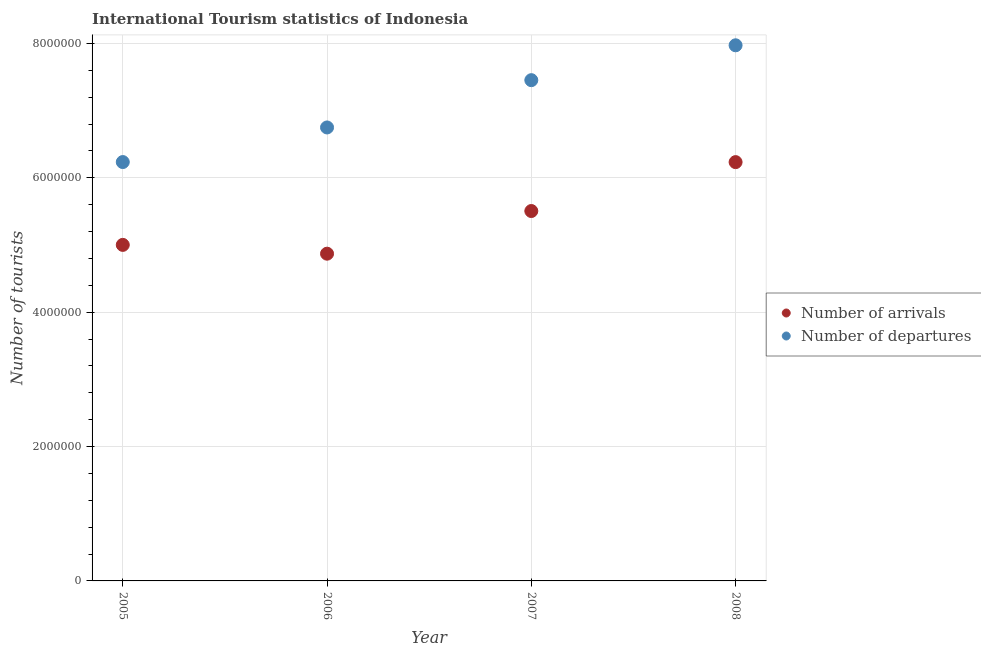How many different coloured dotlines are there?
Ensure brevity in your answer.  2. Is the number of dotlines equal to the number of legend labels?
Your response must be concise. Yes. What is the number of tourist departures in 2008?
Make the answer very short. 7.97e+06. Across all years, what is the maximum number of tourist departures?
Offer a very short reply. 7.97e+06. Across all years, what is the minimum number of tourist departures?
Keep it short and to the point. 6.24e+06. What is the total number of tourist arrivals in the graph?
Provide a short and direct response. 2.16e+07. What is the difference between the number of tourist arrivals in 2005 and that in 2006?
Make the answer very short. 1.31e+05. What is the difference between the number of tourist arrivals in 2006 and the number of tourist departures in 2008?
Your answer should be very brief. -3.10e+06. What is the average number of tourist arrivals per year?
Ensure brevity in your answer.  5.40e+06. In the year 2008, what is the difference between the number of tourist arrivals and number of tourist departures?
Offer a very short reply. -1.74e+06. What is the ratio of the number of tourist arrivals in 2005 to that in 2008?
Your response must be concise. 0.8. Is the difference between the number of tourist departures in 2005 and 2008 greater than the difference between the number of tourist arrivals in 2005 and 2008?
Offer a terse response. No. What is the difference between the highest and the second highest number of tourist departures?
Ensure brevity in your answer.  5.19e+05. What is the difference between the highest and the lowest number of tourist departures?
Your answer should be very brief. 1.74e+06. In how many years, is the number of tourist arrivals greater than the average number of tourist arrivals taken over all years?
Your answer should be very brief. 2. Is the number of tourist departures strictly less than the number of tourist arrivals over the years?
Your answer should be very brief. No. How many years are there in the graph?
Offer a very short reply. 4. Are the values on the major ticks of Y-axis written in scientific E-notation?
Make the answer very short. No. Does the graph contain grids?
Your response must be concise. Yes. How many legend labels are there?
Provide a succinct answer. 2. How are the legend labels stacked?
Make the answer very short. Vertical. What is the title of the graph?
Ensure brevity in your answer.  International Tourism statistics of Indonesia. Does "Lowest 20% of population" appear as one of the legend labels in the graph?
Ensure brevity in your answer.  No. What is the label or title of the X-axis?
Provide a short and direct response. Year. What is the label or title of the Y-axis?
Offer a very short reply. Number of tourists. What is the Number of tourists in Number of arrivals in 2005?
Ensure brevity in your answer.  5.00e+06. What is the Number of tourists of Number of departures in 2005?
Offer a terse response. 6.24e+06. What is the Number of tourists of Number of arrivals in 2006?
Offer a terse response. 4.87e+06. What is the Number of tourists of Number of departures in 2006?
Your answer should be compact. 6.75e+06. What is the Number of tourists in Number of arrivals in 2007?
Your answer should be compact. 5.51e+06. What is the Number of tourists of Number of departures in 2007?
Your answer should be compact. 7.45e+06. What is the Number of tourists in Number of arrivals in 2008?
Offer a terse response. 6.23e+06. What is the Number of tourists in Number of departures in 2008?
Give a very brief answer. 7.97e+06. Across all years, what is the maximum Number of tourists of Number of arrivals?
Make the answer very short. 6.23e+06. Across all years, what is the maximum Number of tourists in Number of departures?
Your response must be concise. 7.97e+06. Across all years, what is the minimum Number of tourists in Number of arrivals?
Provide a short and direct response. 4.87e+06. Across all years, what is the minimum Number of tourists in Number of departures?
Give a very brief answer. 6.24e+06. What is the total Number of tourists in Number of arrivals in the graph?
Ensure brevity in your answer.  2.16e+07. What is the total Number of tourists in Number of departures in the graph?
Offer a terse response. 2.84e+07. What is the difference between the Number of tourists of Number of arrivals in 2005 and that in 2006?
Make the answer very short. 1.31e+05. What is the difference between the Number of tourists in Number of departures in 2005 and that in 2006?
Ensure brevity in your answer.  -5.15e+05. What is the difference between the Number of tourists in Number of arrivals in 2005 and that in 2007?
Give a very brief answer. -5.04e+05. What is the difference between the Number of tourists in Number of departures in 2005 and that in 2007?
Your answer should be very brief. -1.22e+06. What is the difference between the Number of tourists in Number of arrivals in 2005 and that in 2008?
Your response must be concise. -1.23e+06. What is the difference between the Number of tourists in Number of departures in 2005 and that in 2008?
Offer a very short reply. -1.74e+06. What is the difference between the Number of tourists in Number of arrivals in 2006 and that in 2007?
Provide a succinct answer. -6.35e+05. What is the difference between the Number of tourists of Number of departures in 2006 and that in 2007?
Your answer should be very brief. -7.04e+05. What is the difference between the Number of tourists of Number of arrivals in 2006 and that in 2008?
Provide a short and direct response. -1.36e+06. What is the difference between the Number of tourists of Number of departures in 2006 and that in 2008?
Your answer should be very brief. -1.22e+06. What is the difference between the Number of tourists in Number of arrivals in 2007 and that in 2008?
Offer a terse response. -7.28e+05. What is the difference between the Number of tourists of Number of departures in 2007 and that in 2008?
Offer a terse response. -5.19e+05. What is the difference between the Number of tourists in Number of arrivals in 2005 and the Number of tourists in Number of departures in 2006?
Your response must be concise. -1.75e+06. What is the difference between the Number of tourists of Number of arrivals in 2005 and the Number of tourists of Number of departures in 2007?
Keep it short and to the point. -2.45e+06. What is the difference between the Number of tourists of Number of arrivals in 2005 and the Number of tourists of Number of departures in 2008?
Your answer should be very brief. -2.97e+06. What is the difference between the Number of tourists of Number of arrivals in 2006 and the Number of tourists of Number of departures in 2007?
Your answer should be compact. -2.58e+06. What is the difference between the Number of tourists of Number of arrivals in 2006 and the Number of tourists of Number of departures in 2008?
Keep it short and to the point. -3.10e+06. What is the difference between the Number of tourists of Number of arrivals in 2007 and the Number of tourists of Number of departures in 2008?
Offer a terse response. -2.47e+06. What is the average Number of tourists of Number of arrivals per year?
Make the answer very short. 5.40e+06. What is the average Number of tourists in Number of departures per year?
Your answer should be compact. 7.10e+06. In the year 2005, what is the difference between the Number of tourists in Number of arrivals and Number of tourists in Number of departures?
Ensure brevity in your answer.  -1.23e+06. In the year 2006, what is the difference between the Number of tourists in Number of arrivals and Number of tourists in Number of departures?
Provide a succinct answer. -1.88e+06. In the year 2007, what is the difference between the Number of tourists in Number of arrivals and Number of tourists in Number of departures?
Your answer should be compact. -1.95e+06. In the year 2008, what is the difference between the Number of tourists in Number of arrivals and Number of tourists in Number of departures?
Provide a succinct answer. -1.74e+06. What is the ratio of the Number of tourists of Number of arrivals in 2005 to that in 2006?
Offer a very short reply. 1.03. What is the ratio of the Number of tourists in Number of departures in 2005 to that in 2006?
Your answer should be compact. 0.92. What is the ratio of the Number of tourists in Number of arrivals in 2005 to that in 2007?
Make the answer very short. 0.91. What is the ratio of the Number of tourists of Number of departures in 2005 to that in 2007?
Provide a succinct answer. 0.84. What is the ratio of the Number of tourists of Number of arrivals in 2005 to that in 2008?
Give a very brief answer. 0.8. What is the ratio of the Number of tourists in Number of departures in 2005 to that in 2008?
Offer a very short reply. 0.78. What is the ratio of the Number of tourists of Number of arrivals in 2006 to that in 2007?
Offer a terse response. 0.88. What is the ratio of the Number of tourists of Number of departures in 2006 to that in 2007?
Your answer should be compact. 0.91. What is the ratio of the Number of tourists of Number of arrivals in 2006 to that in 2008?
Ensure brevity in your answer.  0.78. What is the ratio of the Number of tourists in Number of departures in 2006 to that in 2008?
Offer a very short reply. 0.85. What is the ratio of the Number of tourists of Number of arrivals in 2007 to that in 2008?
Provide a succinct answer. 0.88. What is the ratio of the Number of tourists in Number of departures in 2007 to that in 2008?
Ensure brevity in your answer.  0.93. What is the difference between the highest and the second highest Number of tourists of Number of arrivals?
Your response must be concise. 7.28e+05. What is the difference between the highest and the second highest Number of tourists of Number of departures?
Your answer should be very brief. 5.19e+05. What is the difference between the highest and the lowest Number of tourists of Number of arrivals?
Keep it short and to the point. 1.36e+06. What is the difference between the highest and the lowest Number of tourists in Number of departures?
Your response must be concise. 1.74e+06. 